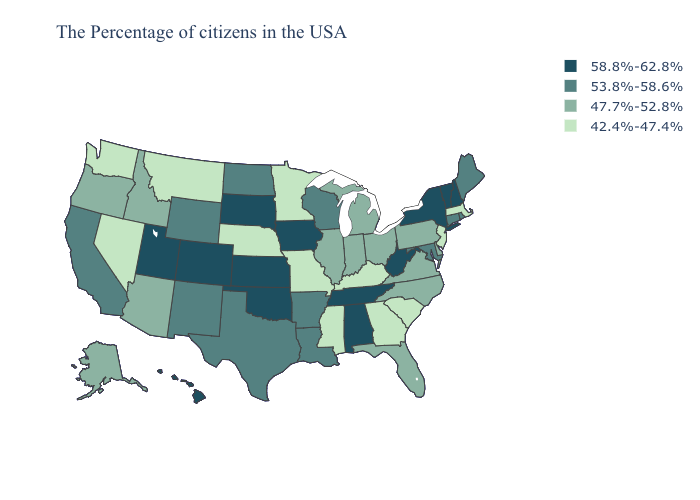What is the value of Montana?
Concise answer only. 42.4%-47.4%. Name the states that have a value in the range 42.4%-47.4%?
Keep it brief. Massachusetts, New Jersey, South Carolina, Georgia, Kentucky, Mississippi, Missouri, Minnesota, Nebraska, Montana, Nevada, Washington. Name the states that have a value in the range 53.8%-58.6%?
Concise answer only. Maine, Rhode Island, Connecticut, Maryland, Wisconsin, Louisiana, Arkansas, Texas, North Dakota, Wyoming, New Mexico, California. What is the value of North Carolina?
Write a very short answer. 47.7%-52.8%. Name the states that have a value in the range 42.4%-47.4%?
Concise answer only. Massachusetts, New Jersey, South Carolina, Georgia, Kentucky, Mississippi, Missouri, Minnesota, Nebraska, Montana, Nevada, Washington. Which states have the lowest value in the USA?
Be succinct. Massachusetts, New Jersey, South Carolina, Georgia, Kentucky, Mississippi, Missouri, Minnesota, Nebraska, Montana, Nevada, Washington. Does Mississippi have a higher value than Arkansas?
Concise answer only. No. What is the value of Montana?
Be succinct. 42.4%-47.4%. Which states have the lowest value in the South?
Keep it brief. South Carolina, Georgia, Kentucky, Mississippi. Which states hav the highest value in the Northeast?
Be succinct. New Hampshire, Vermont, New York. Is the legend a continuous bar?
Concise answer only. No. What is the highest value in states that border Illinois?
Give a very brief answer. 58.8%-62.8%. What is the value of California?
Write a very short answer. 53.8%-58.6%. What is the highest value in the USA?
Concise answer only. 58.8%-62.8%. Does Wisconsin have a higher value than Massachusetts?
Keep it brief. Yes. 